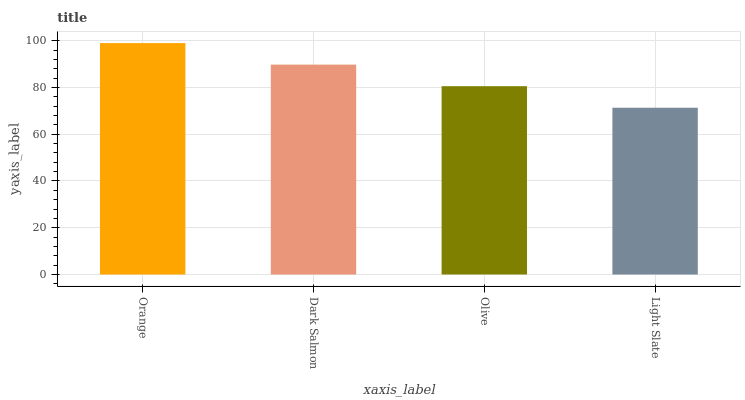Is Light Slate the minimum?
Answer yes or no. Yes. Is Orange the maximum?
Answer yes or no. Yes. Is Dark Salmon the minimum?
Answer yes or no. No. Is Dark Salmon the maximum?
Answer yes or no. No. Is Orange greater than Dark Salmon?
Answer yes or no. Yes. Is Dark Salmon less than Orange?
Answer yes or no. Yes. Is Dark Salmon greater than Orange?
Answer yes or no. No. Is Orange less than Dark Salmon?
Answer yes or no. No. Is Dark Salmon the high median?
Answer yes or no. Yes. Is Olive the low median?
Answer yes or no. Yes. Is Orange the high median?
Answer yes or no. No. Is Light Slate the low median?
Answer yes or no. No. 